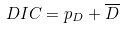<formula> <loc_0><loc_0><loc_500><loc_500>D I C = p _ { D } + \overline { D }</formula> 